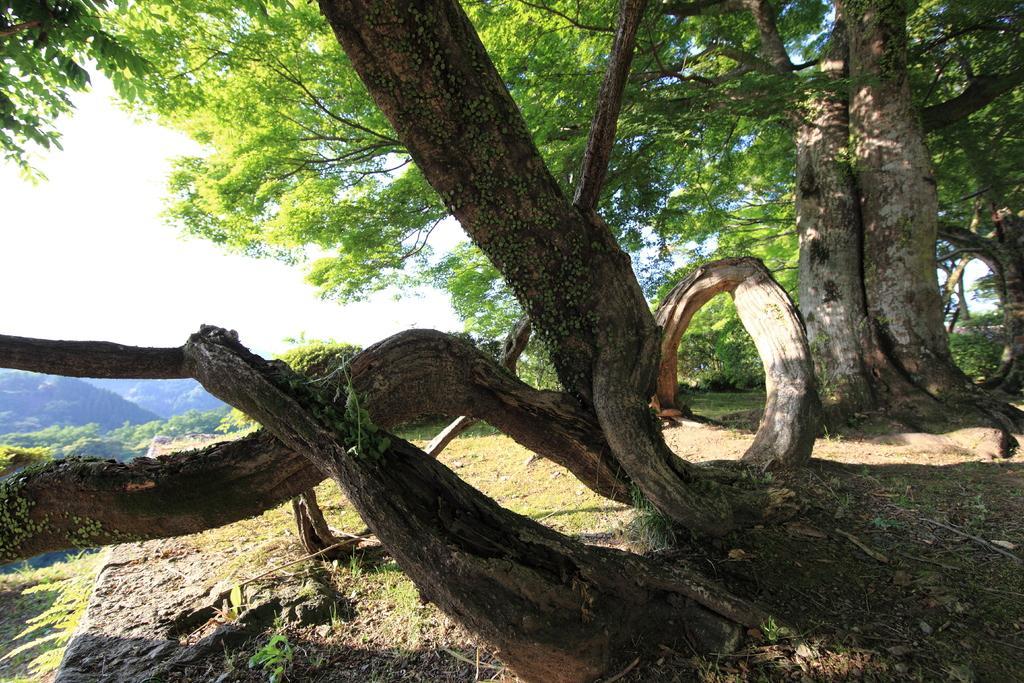Can you describe this image briefly? This is an outside view. Here I can see many trees on the ground. On the left side, I can see the sky. 